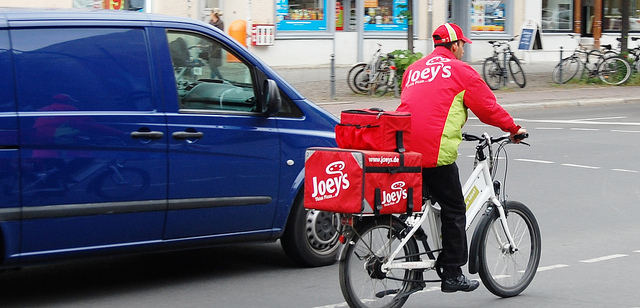<image>What boy is watching? Is he riding or stop for someone? I am not sure what the boy is watching or whether he is riding or stopped. What boy is watching? Is he riding or stop for someone? I don't know what boy is watching. It is not clear if he is riding or stopped for someone. 